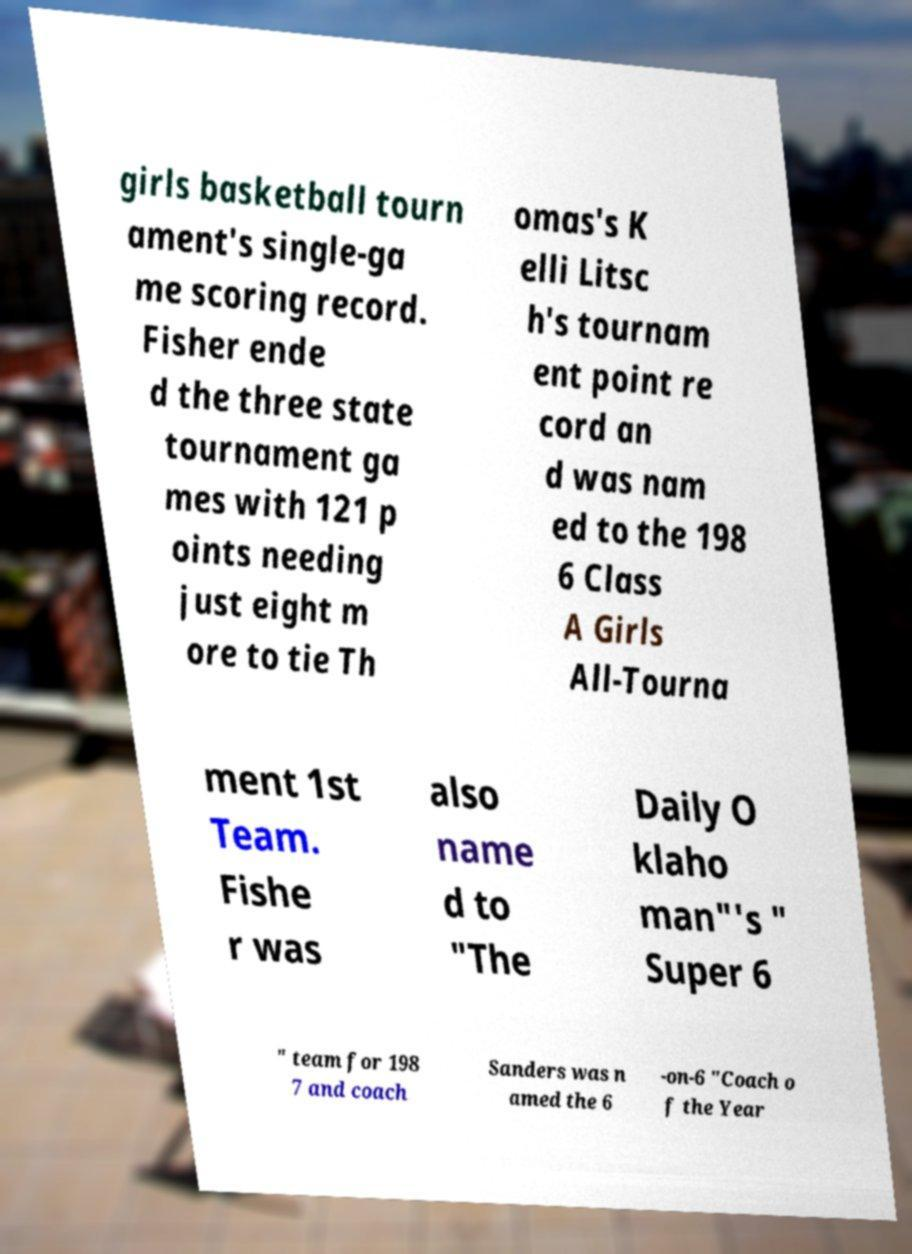There's text embedded in this image that I need extracted. Can you transcribe it verbatim? girls basketball tourn ament's single-ga me scoring record. Fisher ende d the three state tournament ga mes with 121 p oints needing just eight m ore to tie Th omas's K elli Litsc h's tournam ent point re cord an d was nam ed to the 198 6 Class A Girls All-Tourna ment 1st Team. Fishe r was also name d to "The Daily O klaho man"'s " Super 6 " team for 198 7 and coach Sanders was n amed the 6 -on-6 "Coach o f the Year 